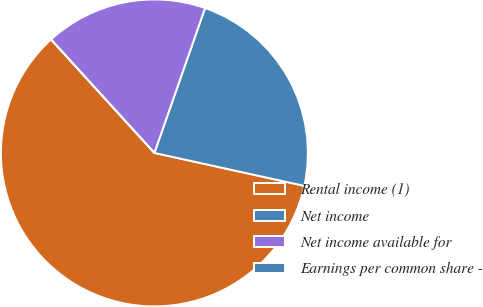<chart> <loc_0><loc_0><loc_500><loc_500><pie_chart><fcel>Rental income (1)<fcel>Net income<fcel>Net income available for<fcel>Earnings per common share -<nl><fcel>59.81%<fcel>23.09%<fcel>17.11%<fcel>0.0%<nl></chart> 